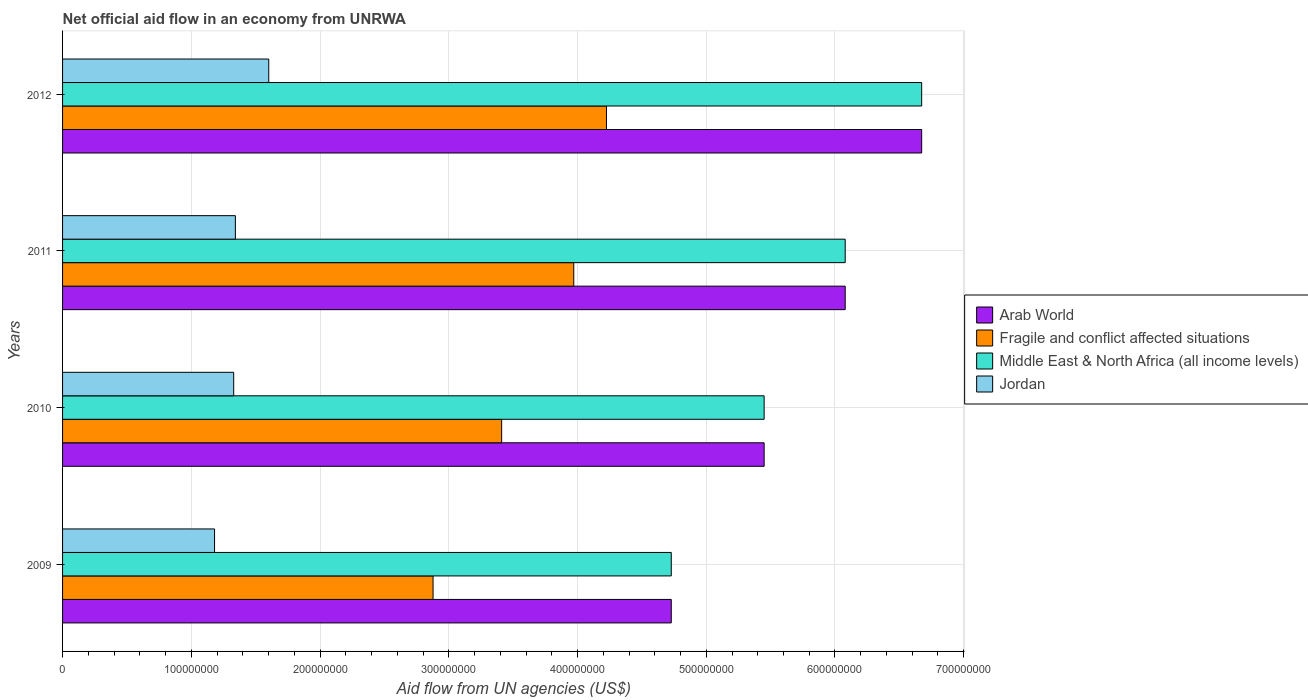How many different coloured bars are there?
Offer a terse response. 4. Are the number of bars per tick equal to the number of legend labels?
Make the answer very short. Yes. Are the number of bars on each tick of the Y-axis equal?
Your answer should be very brief. Yes. How many bars are there on the 1st tick from the bottom?
Keep it short and to the point. 4. What is the net official aid flow in Arab World in 2011?
Offer a very short reply. 6.08e+08. Across all years, what is the maximum net official aid flow in Arab World?
Offer a terse response. 6.67e+08. Across all years, what is the minimum net official aid flow in Jordan?
Offer a very short reply. 1.18e+08. What is the total net official aid flow in Jordan in the graph?
Your answer should be very brief. 5.45e+08. What is the difference between the net official aid flow in Arab World in 2010 and that in 2011?
Your response must be concise. -6.30e+07. What is the difference between the net official aid flow in Arab World in 2009 and the net official aid flow in Jordan in 2011?
Your answer should be very brief. 3.39e+08. What is the average net official aid flow in Arab World per year?
Make the answer very short. 5.73e+08. In the year 2009, what is the difference between the net official aid flow in Middle East & North Africa (all income levels) and net official aid flow in Arab World?
Offer a terse response. 0. What is the ratio of the net official aid flow in Fragile and conflict affected situations in 2010 to that in 2012?
Your response must be concise. 0.81. Is the difference between the net official aid flow in Middle East & North Africa (all income levels) in 2010 and 2012 greater than the difference between the net official aid flow in Arab World in 2010 and 2012?
Offer a terse response. No. What is the difference between the highest and the second highest net official aid flow in Jordan?
Make the answer very short. 2.59e+07. What is the difference between the highest and the lowest net official aid flow in Middle East & North Africa (all income levels)?
Your response must be concise. 1.95e+08. Is the sum of the net official aid flow in Arab World in 2009 and 2011 greater than the maximum net official aid flow in Middle East & North Africa (all income levels) across all years?
Provide a succinct answer. Yes. What does the 4th bar from the top in 2012 represents?
Your answer should be very brief. Arab World. What does the 1st bar from the bottom in 2010 represents?
Your answer should be compact. Arab World. Is it the case that in every year, the sum of the net official aid flow in Jordan and net official aid flow in Fragile and conflict affected situations is greater than the net official aid flow in Middle East & North Africa (all income levels)?
Offer a very short reply. No. How many bars are there?
Provide a short and direct response. 16. Are all the bars in the graph horizontal?
Ensure brevity in your answer.  Yes. Are the values on the major ticks of X-axis written in scientific E-notation?
Your answer should be compact. No. Where does the legend appear in the graph?
Your answer should be very brief. Center right. How are the legend labels stacked?
Make the answer very short. Vertical. What is the title of the graph?
Ensure brevity in your answer.  Net official aid flow in an economy from UNRWA. What is the label or title of the X-axis?
Your answer should be very brief. Aid flow from UN agencies (US$). What is the Aid flow from UN agencies (US$) of Arab World in 2009?
Provide a short and direct response. 4.73e+08. What is the Aid flow from UN agencies (US$) in Fragile and conflict affected situations in 2009?
Your response must be concise. 2.88e+08. What is the Aid flow from UN agencies (US$) of Middle East & North Africa (all income levels) in 2009?
Keep it short and to the point. 4.73e+08. What is the Aid flow from UN agencies (US$) in Jordan in 2009?
Your response must be concise. 1.18e+08. What is the Aid flow from UN agencies (US$) in Arab World in 2010?
Your answer should be compact. 5.45e+08. What is the Aid flow from UN agencies (US$) of Fragile and conflict affected situations in 2010?
Your response must be concise. 3.41e+08. What is the Aid flow from UN agencies (US$) in Middle East & North Africa (all income levels) in 2010?
Provide a short and direct response. 5.45e+08. What is the Aid flow from UN agencies (US$) of Jordan in 2010?
Provide a short and direct response. 1.33e+08. What is the Aid flow from UN agencies (US$) of Arab World in 2011?
Provide a succinct answer. 6.08e+08. What is the Aid flow from UN agencies (US$) in Fragile and conflict affected situations in 2011?
Make the answer very short. 3.97e+08. What is the Aid flow from UN agencies (US$) in Middle East & North Africa (all income levels) in 2011?
Your response must be concise. 6.08e+08. What is the Aid flow from UN agencies (US$) of Jordan in 2011?
Ensure brevity in your answer.  1.34e+08. What is the Aid flow from UN agencies (US$) in Arab World in 2012?
Keep it short and to the point. 6.67e+08. What is the Aid flow from UN agencies (US$) in Fragile and conflict affected situations in 2012?
Keep it short and to the point. 4.22e+08. What is the Aid flow from UN agencies (US$) of Middle East & North Africa (all income levels) in 2012?
Keep it short and to the point. 6.67e+08. What is the Aid flow from UN agencies (US$) in Jordan in 2012?
Keep it short and to the point. 1.60e+08. Across all years, what is the maximum Aid flow from UN agencies (US$) of Arab World?
Ensure brevity in your answer.  6.67e+08. Across all years, what is the maximum Aid flow from UN agencies (US$) of Fragile and conflict affected situations?
Make the answer very short. 4.22e+08. Across all years, what is the maximum Aid flow from UN agencies (US$) in Middle East & North Africa (all income levels)?
Give a very brief answer. 6.67e+08. Across all years, what is the maximum Aid flow from UN agencies (US$) of Jordan?
Give a very brief answer. 1.60e+08. Across all years, what is the minimum Aid flow from UN agencies (US$) in Arab World?
Offer a terse response. 4.73e+08. Across all years, what is the minimum Aid flow from UN agencies (US$) in Fragile and conflict affected situations?
Give a very brief answer. 2.88e+08. Across all years, what is the minimum Aid flow from UN agencies (US$) of Middle East & North Africa (all income levels)?
Make the answer very short. 4.73e+08. Across all years, what is the minimum Aid flow from UN agencies (US$) in Jordan?
Provide a succinct answer. 1.18e+08. What is the total Aid flow from UN agencies (US$) in Arab World in the graph?
Give a very brief answer. 2.29e+09. What is the total Aid flow from UN agencies (US$) in Fragile and conflict affected situations in the graph?
Your answer should be compact. 1.45e+09. What is the total Aid flow from UN agencies (US$) in Middle East & North Africa (all income levels) in the graph?
Your response must be concise. 2.29e+09. What is the total Aid flow from UN agencies (US$) in Jordan in the graph?
Give a very brief answer. 5.45e+08. What is the difference between the Aid flow from UN agencies (US$) in Arab World in 2009 and that in 2010?
Offer a very short reply. -7.21e+07. What is the difference between the Aid flow from UN agencies (US$) of Fragile and conflict affected situations in 2009 and that in 2010?
Ensure brevity in your answer.  -5.33e+07. What is the difference between the Aid flow from UN agencies (US$) in Middle East & North Africa (all income levels) in 2009 and that in 2010?
Offer a very short reply. -7.21e+07. What is the difference between the Aid flow from UN agencies (US$) of Jordan in 2009 and that in 2010?
Keep it short and to the point. -1.49e+07. What is the difference between the Aid flow from UN agencies (US$) in Arab World in 2009 and that in 2011?
Your answer should be very brief. -1.35e+08. What is the difference between the Aid flow from UN agencies (US$) of Fragile and conflict affected situations in 2009 and that in 2011?
Ensure brevity in your answer.  -1.09e+08. What is the difference between the Aid flow from UN agencies (US$) in Middle East & North Africa (all income levels) in 2009 and that in 2011?
Provide a succinct answer. -1.35e+08. What is the difference between the Aid flow from UN agencies (US$) of Jordan in 2009 and that in 2011?
Your response must be concise. -1.62e+07. What is the difference between the Aid flow from UN agencies (US$) in Arab World in 2009 and that in 2012?
Ensure brevity in your answer.  -1.95e+08. What is the difference between the Aid flow from UN agencies (US$) in Fragile and conflict affected situations in 2009 and that in 2012?
Keep it short and to the point. -1.35e+08. What is the difference between the Aid flow from UN agencies (US$) of Middle East & North Africa (all income levels) in 2009 and that in 2012?
Make the answer very short. -1.95e+08. What is the difference between the Aid flow from UN agencies (US$) of Jordan in 2009 and that in 2012?
Your answer should be compact. -4.21e+07. What is the difference between the Aid flow from UN agencies (US$) of Arab World in 2010 and that in 2011?
Offer a very short reply. -6.30e+07. What is the difference between the Aid flow from UN agencies (US$) in Fragile and conflict affected situations in 2010 and that in 2011?
Your answer should be very brief. -5.60e+07. What is the difference between the Aid flow from UN agencies (US$) in Middle East & North Africa (all income levels) in 2010 and that in 2011?
Make the answer very short. -6.30e+07. What is the difference between the Aid flow from UN agencies (US$) in Jordan in 2010 and that in 2011?
Keep it short and to the point. -1.29e+06. What is the difference between the Aid flow from UN agencies (US$) of Arab World in 2010 and that in 2012?
Make the answer very short. -1.22e+08. What is the difference between the Aid flow from UN agencies (US$) of Fragile and conflict affected situations in 2010 and that in 2012?
Provide a short and direct response. -8.14e+07. What is the difference between the Aid flow from UN agencies (US$) in Middle East & North Africa (all income levels) in 2010 and that in 2012?
Offer a terse response. -1.22e+08. What is the difference between the Aid flow from UN agencies (US$) of Jordan in 2010 and that in 2012?
Make the answer very short. -2.72e+07. What is the difference between the Aid flow from UN agencies (US$) of Arab World in 2011 and that in 2012?
Offer a terse response. -5.94e+07. What is the difference between the Aid flow from UN agencies (US$) in Fragile and conflict affected situations in 2011 and that in 2012?
Offer a very short reply. -2.54e+07. What is the difference between the Aid flow from UN agencies (US$) of Middle East & North Africa (all income levels) in 2011 and that in 2012?
Give a very brief answer. -5.94e+07. What is the difference between the Aid flow from UN agencies (US$) in Jordan in 2011 and that in 2012?
Provide a short and direct response. -2.59e+07. What is the difference between the Aid flow from UN agencies (US$) of Arab World in 2009 and the Aid flow from UN agencies (US$) of Fragile and conflict affected situations in 2010?
Your answer should be very brief. 1.32e+08. What is the difference between the Aid flow from UN agencies (US$) of Arab World in 2009 and the Aid flow from UN agencies (US$) of Middle East & North Africa (all income levels) in 2010?
Make the answer very short. -7.21e+07. What is the difference between the Aid flow from UN agencies (US$) in Arab World in 2009 and the Aid flow from UN agencies (US$) in Jordan in 2010?
Make the answer very short. 3.40e+08. What is the difference between the Aid flow from UN agencies (US$) of Fragile and conflict affected situations in 2009 and the Aid flow from UN agencies (US$) of Middle East & North Africa (all income levels) in 2010?
Offer a very short reply. -2.57e+08. What is the difference between the Aid flow from UN agencies (US$) in Fragile and conflict affected situations in 2009 and the Aid flow from UN agencies (US$) in Jordan in 2010?
Your answer should be compact. 1.55e+08. What is the difference between the Aid flow from UN agencies (US$) of Middle East & North Africa (all income levels) in 2009 and the Aid flow from UN agencies (US$) of Jordan in 2010?
Your answer should be very brief. 3.40e+08. What is the difference between the Aid flow from UN agencies (US$) in Arab World in 2009 and the Aid flow from UN agencies (US$) in Fragile and conflict affected situations in 2011?
Offer a terse response. 7.57e+07. What is the difference between the Aid flow from UN agencies (US$) in Arab World in 2009 and the Aid flow from UN agencies (US$) in Middle East & North Africa (all income levels) in 2011?
Your answer should be compact. -1.35e+08. What is the difference between the Aid flow from UN agencies (US$) in Arab World in 2009 and the Aid flow from UN agencies (US$) in Jordan in 2011?
Keep it short and to the point. 3.39e+08. What is the difference between the Aid flow from UN agencies (US$) of Fragile and conflict affected situations in 2009 and the Aid flow from UN agencies (US$) of Middle East & North Africa (all income levels) in 2011?
Your response must be concise. -3.20e+08. What is the difference between the Aid flow from UN agencies (US$) of Fragile and conflict affected situations in 2009 and the Aid flow from UN agencies (US$) of Jordan in 2011?
Ensure brevity in your answer.  1.54e+08. What is the difference between the Aid flow from UN agencies (US$) in Middle East & North Africa (all income levels) in 2009 and the Aid flow from UN agencies (US$) in Jordan in 2011?
Provide a succinct answer. 3.39e+08. What is the difference between the Aid flow from UN agencies (US$) of Arab World in 2009 and the Aid flow from UN agencies (US$) of Fragile and conflict affected situations in 2012?
Offer a very short reply. 5.03e+07. What is the difference between the Aid flow from UN agencies (US$) of Arab World in 2009 and the Aid flow from UN agencies (US$) of Middle East & North Africa (all income levels) in 2012?
Your response must be concise. -1.95e+08. What is the difference between the Aid flow from UN agencies (US$) in Arab World in 2009 and the Aid flow from UN agencies (US$) in Jordan in 2012?
Offer a terse response. 3.13e+08. What is the difference between the Aid flow from UN agencies (US$) of Fragile and conflict affected situations in 2009 and the Aid flow from UN agencies (US$) of Middle East & North Africa (all income levels) in 2012?
Your response must be concise. -3.80e+08. What is the difference between the Aid flow from UN agencies (US$) of Fragile and conflict affected situations in 2009 and the Aid flow from UN agencies (US$) of Jordan in 2012?
Keep it short and to the point. 1.28e+08. What is the difference between the Aid flow from UN agencies (US$) of Middle East & North Africa (all income levels) in 2009 and the Aid flow from UN agencies (US$) of Jordan in 2012?
Make the answer very short. 3.13e+08. What is the difference between the Aid flow from UN agencies (US$) in Arab World in 2010 and the Aid flow from UN agencies (US$) in Fragile and conflict affected situations in 2011?
Offer a terse response. 1.48e+08. What is the difference between the Aid flow from UN agencies (US$) in Arab World in 2010 and the Aid flow from UN agencies (US$) in Middle East & North Africa (all income levels) in 2011?
Offer a very short reply. -6.30e+07. What is the difference between the Aid flow from UN agencies (US$) of Arab World in 2010 and the Aid flow from UN agencies (US$) of Jordan in 2011?
Offer a terse response. 4.11e+08. What is the difference between the Aid flow from UN agencies (US$) of Fragile and conflict affected situations in 2010 and the Aid flow from UN agencies (US$) of Middle East & North Africa (all income levels) in 2011?
Provide a short and direct response. -2.67e+08. What is the difference between the Aid flow from UN agencies (US$) of Fragile and conflict affected situations in 2010 and the Aid flow from UN agencies (US$) of Jordan in 2011?
Make the answer very short. 2.07e+08. What is the difference between the Aid flow from UN agencies (US$) in Middle East & North Africa (all income levels) in 2010 and the Aid flow from UN agencies (US$) in Jordan in 2011?
Offer a very short reply. 4.11e+08. What is the difference between the Aid flow from UN agencies (US$) of Arab World in 2010 and the Aid flow from UN agencies (US$) of Fragile and conflict affected situations in 2012?
Provide a succinct answer. 1.22e+08. What is the difference between the Aid flow from UN agencies (US$) in Arab World in 2010 and the Aid flow from UN agencies (US$) in Middle East & North Africa (all income levels) in 2012?
Provide a succinct answer. -1.22e+08. What is the difference between the Aid flow from UN agencies (US$) of Arab World in 2010 and the Aid flow from UN agencies (US$) of Jordan in 2012?
Offer a terse response. 3.85e+08. What is the difference between the Aid flow from UN agencies (US$) in Fragile and conflict affected situations in 2010 and the Aid flow from UN agencies (US$) in Middle East & North Africa (all income levels) in 2012?
Provide a succinct answer. -3.26e+08. What is the difference between the Aid flow from UN agencies (US$) in Fragile and conflict affected situations in 2010 and the Aid flow from UN agencies (US$) in Jordan in 2012?
Your response must be concise. 1.81e+08. What is the difference between the Aid flow from UN agencies (US$) of Middle East & North Africa (all income levels) in 2010 and the Aid flow from UN agencies (US$) of Jordan in 2012?
Your answer should be very brief. 3.85e+08. What is the difference between the Aid flow from UN agencies (US$) in Arab World in 2011 and the Aid flow from UN agencies (US$) in Fragile and conflict affected situations in 2012?
Your answer should be very brief. 1.85e+08. What is the difference between the Aid flow from UN agencies (US$) in Arab World in 2011 and the Aid flow from UN agencies (US$) in Middle East & North Africa (all income levels) in 2012?
Provide a succinct answer. -5.94e+07. What is the difference between the Aid flow from UN agencies (US$) of Arab World in 2011 and the Aid flow from UN agencies (US$) of Jordan in 2012?
Provide a short and direct response. 4.48e+08. What is the difference between the Aid flow from UN agencies (US$) of Fragile and conflict affected situations in 2011 and the Aid flow from UN agencies (US$) of Middle East & North Africa (all income levels) in 2012?
Your response must be concise. -2.70e+08. What is the difference between the Aid flow from UN agencies (US$) of Fragile and conflict affected situations in 2011 and the Aid flow from UN agencies (US$) of Jordan in 2012?
Your response must be concise. 2.37e+08. What is the difference between the Aid flow from UN agencies (US$) in Middle East & North Africa (all income levels) in 2011 and the Aid flow from UN agencies (US$) in Jordan in 2012?
Provide a short and direct response. 4.48e+08. What is the average Aid flow from UN agencies (US$) in Arab World per year?
Your response must be concise. 5.73e+08. What is the average Aid flow from UN agencies (US$) in Fragile and conflict affected situations per year?
Give a very brief answer. 3.62e+08. What is the average Aid flow from UN agencies (US$) in Middle East & North Africa (all income levels) per year?
Provide a succinct answer. 5.73e+08. What is the average Aid flow from UN agencies (US$) in Jordan per year?
Your response must be concise. 1.36e+08. In the year 2009, what is the difference between the Aid flow from UN agencies (US$) of Arab World and Aid flow from UN agencies (US$) of Fragile and conflict affected situations?
Ensure brevity in your answer.  1.85e+08. In the year 2009, what is the difference between the Aid flow from UN agencies (US$) of Arab World and Aid flow from UN agencies (US$) of Jordan?
Keep it short and to the point. 3.55e+08. In the year 2009, what is the difference between the Aid flow from UN agencies (US$) of Fragile and conflict affected situations and Aid flow from UN agencies (US$) of Middle East & North Africa (all income levels)?
Your response must be concise. -1.85e+08. In the year 2009, what is the difference between the Aid flow from UN agencies (US$) of Fragile and conflict affected situations and Aid flow from UN agencies (US$) of Jordan?
Offer a very short reply. 1.70e+08. In the year 2009, what is the difference between the Aid flow from UN agencies (US$) in Middle East & North Africa (all income levels) and Aid flow from UN agencies (US$) in Jordan?
Keep it short and to the point. 3.55e+08. In the year 2010, what is the difference between the Aid flow from UN agencies (US$) in Arab World and Aid flow from UN agencies (US$) in Fragile and conflict affected situations?
Offer a terse response. 2.04e+08. In the year 2010, what is the difference between the Aid flow from UN agencies (US$) in Arab World and Aid flow from UN agencies (US$) in Jordan?
Provide a short and direct response. 4.12e+08. In the year 2010, what is the difference between the Aid flow from UN agencies (US$) of Fragile and conflict affected situations and Aid flow from UN agencies (US$) of Middle East & North Africa (all income levels)?
Offer a terse response. -2.04e+08. In the year 2010, what is the difference between the Aid flow from UN agencies (US$) of Fragile and conflict affected situations and Aid flow from UN agencies (US$) of Jordan?
Keep it short and to the point. 2.08e+08. In the year 2010, what is the difference between the Aid flow from UN agencies (US$) of Middle East & North Africa (all income levels) and Aid flow from UN agencies (US$) of Jordan?
Make the answer very short. 4.12e+08. In the year 2011, what is the difference between the Aid flow from UN agencies (US$) in Arab World and Aid flow from UN agencies (US$) in Fragile and conflict affected situations?
Your response must be concise. 2.11e+08. In the year 2011, what is the difference between the Aid flow from UN agencies (US$) of Arab World and Aid flow from UN agencies (US$) of Middle East & North Africa (all income levels)?
Ensure brevity in your answer.  0. In the year 2011, what is the difference between the Aid flow from UN agencies (US$) in Arab World and Aid flow from UN agencies (US$) in Jordan?
Offer a terse response. 4.74e+08. In the year 2011, what is the difference between the Aid flow from UN agencies (US$) of Fragile and conflict affected situations and Aid flow from UN agencies (US$) of Middle East & North Africa (all income levels)?
Provide a short and direct response. -2.11e+08. In the year 2011, what is the difference between the Aid flow from UN agencies (US$) of Fragile and conflict affected situations and Aid flow from UN agencies (US$) of Jordan?
Ensure brevity in your answer.  2.63e+08. In the year 2011, what is the difference between the Aid flow from UN agencies (US$) in Middle East & North Africa (all income levels) and Aid flow from UN agencies (US$) in Jordan?
Keep it short and to the point. 4.74e+08. In the year 2012, what is the difference between the Aid flow from UN agencies (US$) of Arab World and Aid flow from UN agencies (US$) of Fragile and conflict affected situations?
Offer a very short reply. 2.45e+08. In the year 2012, what is the difference between the Aid flow from UN agencies (US$) of Arab World and Aid flow from UN agencies (US$) of Jordan?
Offer a terse response. 5.07e+08. In the year 2012, what is the difference between the Aid flow from UN agencies (US$) of Fragile and conflict affected situations and Aid flow from UN agencies (US$) of Middle East & North Africa (all income levels)?
Give a very brief answer. -2.45e+08. In the year 2012, what is the difference between the Aid flow from UN agencies (US$) in Fragile and conflict affected situations and Aid flow from UN agencies (US$) in Jordan?
Your answer should be compact. 2.62e+08. In the year 2012, what is the difference between the Aid flow from UN agencies (US$) in Middle East & North Africa (all income levels) and Aid flow from UN agencies (US$) in Jordan?
Make the answer very short. 5.07e+08. What is the ratio of the Aid flow from UN agencies (US$) in Arab World in 2009 to that in 2010?
Your answer should be compact. 0.87. What is the ratio of the Aid flow from UN agencies (US$) of Fragile and conflict affected situations in 2009 to that in 2010?
Your answer should be very brief. 0.84. What is the ratio of the Aid flow from UN agencies (US$) of Middle East & North Africa (all income levels) in 2009 to that in 2010?
Offer a very short reply. 0.87. What is the ratio of the Aid flow from UN agencies (US$) of Jordan in 2009 to that in 2010?
Make the answer very short. 0.89. What is the ratio of the Aid flow from UN agencies (US$) of Fragile and conflict affected situations in 2009 to that in 2011?
Your response must be concise. 0.72. What is the ratio of the Aid flow from UN agencies (US$) in Jordan in 2009 to that in 2011?
Offer a terse response. 0.88. What is the ratio of the Aid flow from UN agencies (US$) of Arab World in 2009 to that in 2012?
Your answer should be very brief. 0.71. What is the ratio of the Aid flow from UN agencies (US$) in Fragile and conflict affected situations in 2009 to that in 2012?
Keep it short and to the point. 0.68. What is the ratio of the Aid flow from UN agencies (US$) of Middle East & North Africa (all income levels) in 2009 to that in 2012?
Offer a very short reply. 0.71. What is the ratio of the Aid flow from UN agencies (US$) of Jordan in 2009 to that in 2012?
Keep it short and to the point. 0.74. What is the ratio of the Aid flow from UN agencies (US$) in Arab World in 2010 to that in 2011?
Give a very brief answer. 0.9. What is the ratio of the Aid flow from UN agencies (US$) of Fragile and conflict affected situations in 2010 to that in 2011?
Keep it short and to the point. 0.86. What is the ratio of the Aid flow from UN agencies (US$) in Middle East & North Africa (all income levels) in 2010 to that in 2011?
Your answer should be compact. 0.9. What is the ratio of the Aid flow from UN agencies (US$) in Arab World in 2010 to that in 2012?
Provide a short and direct response. 0.82. What is the ratio of the Aid flow from UN agencies (US$) of Fragile and conflict affected situations in 2010 to that in 2012?
Offer a terse response. 0.81. What is the ratio of the Aid flow from UN agencies (US$) of Middle East & North Africa (all income levels) in 2010 to that in 2012?
Ensure brevity in your answer.  0.82. What is the ratio of the Aid flow from UN agencies (US$) of Jordan in 2010 to that in 2012?
Provide a succinct answer. 0.83. What is the ratio of the Aid flow from UN agencies (US$) in Arab World in 2011 to that in 2012?
Your answer should be very brief. 0.91. What is the ratio of the Aid flow from UN agencies (US$) of Fragile and conflict affected situations in 2011 to that in 2012?
Provide a short and direct response. 0.94. What is the ratio of the Aid flow from UN agencies (US$) of Middle East & North Africa (all income levels) in 2011 to that in 2012?
Offer a terse response. 0.91. What is the ratio of the Aid flow from UN agencies (US$) of Jordan in 2011 to that in 2012?
Provide a short and direct response. 0.84. What is the difference between the highest and the second highest Aid flow from UN agencies (US$) in Arab World?
Give a very brief answer. 5.94e+07. What is the difference between the highest and the second highest Aid flow from UN agencies (US$) in Fragile and conflict affected situations?
Your response must be concise. 2.54e+07. What is the difference between the highest and the second highest Aid flow from UN agencies (US$) of Middle East & North Africa (all income levels)?
Offer a very short reply. 5.94e+07. What is the difference between the highest and the second highest Aid flow from UN agencies (US$) of Jordan?
Ensure brevity in your answer.  2.59e+07. What is the difference between the highest and the lowest Aid flow from UN agencies (US$) of Arab World?
Your response must be concise. 1.95e+08. What is the difference between the highest and the lowest Aid flow from UN agencies (US$) of Fragile and conflict affected situations?
Offer a very short reply. 1.35e+08. What is the difference between the highest and the lowest Aid flow from UN agencies (US$) of Middle East & North Africa (all income levels)?
Provide a succinct answer. 1.95e+08. What is the difference between the highest and the lowest Aid flow from UN agencies (US$) of Jordan?
Your response must be concise. 4.21e+07. 